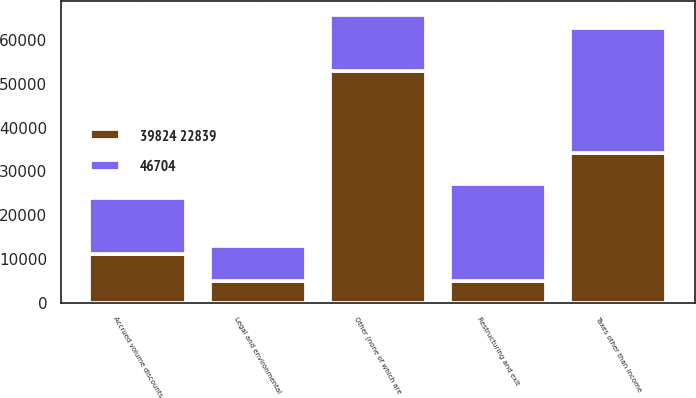<chart> <loc_0><loc_0><loc_500><loc_500><stacked_bar_chart><ecel><fcel>Taxes other than income<fcel>Accrued volume discounts<fcel>Restructuring and exit<fcel>Legal and environmental<fcel>Other (none of which are<nl><fcel>46704<fcel>28452<fcel>12799<fcel>22021<fcel>7868<fcel>12799<nl><fcel>39824 22839<fcel>34229<fcel>11151<fcel>4986<fcel>4967<fcel>52966<nl></chart> 